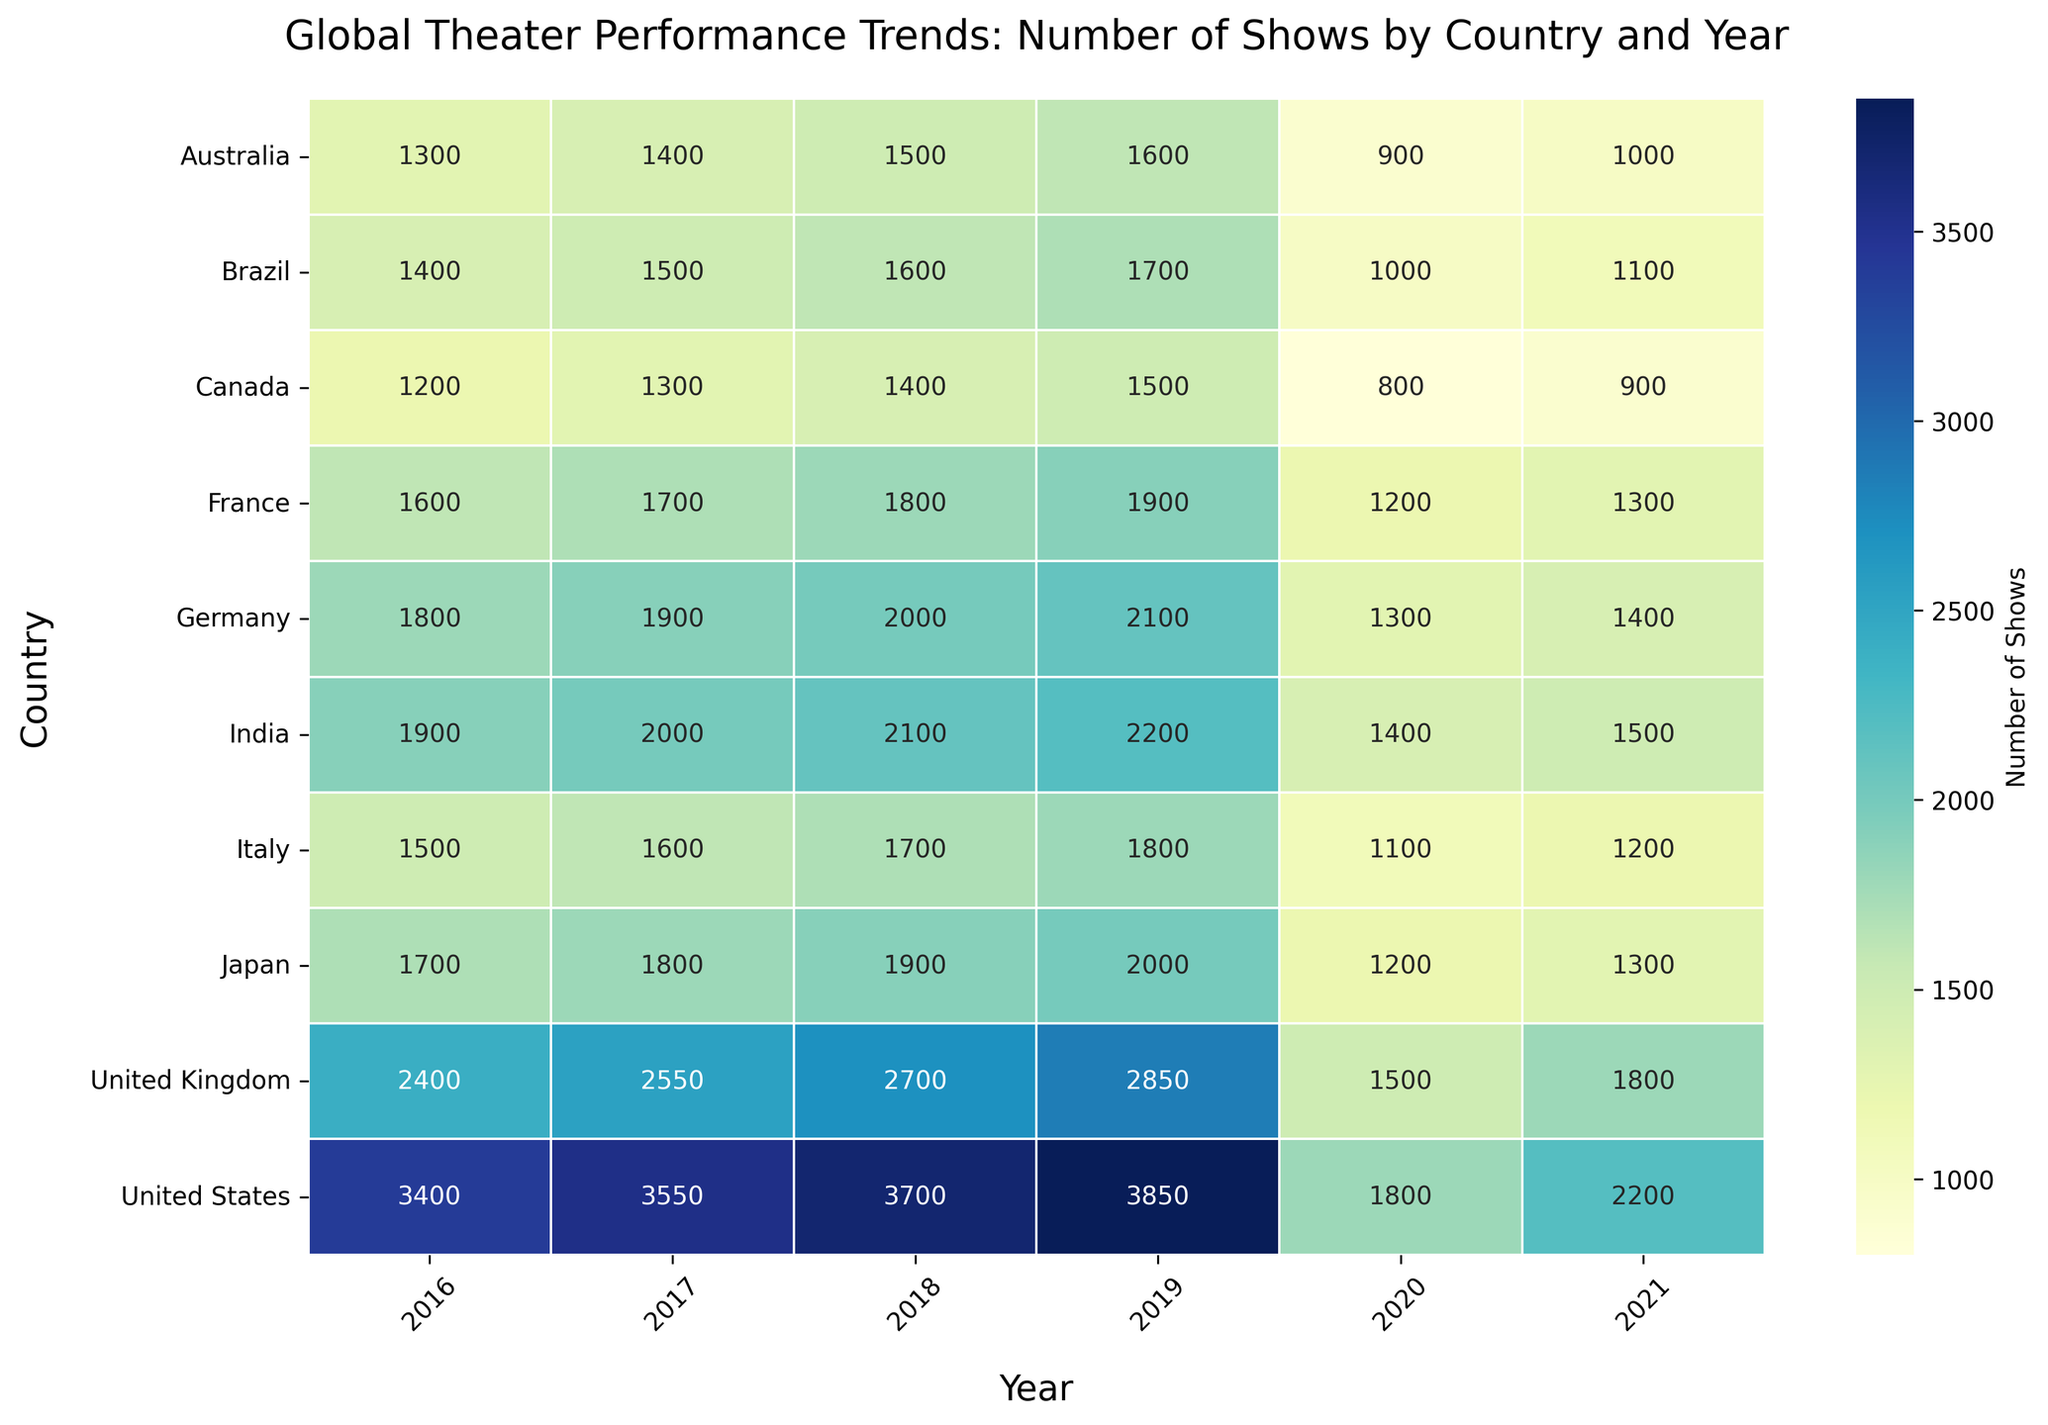What country had the highest number of theater shows in 2019? Look at the row corresponding to 2019 and find the country with the highest value. The United States has the highest number with 3850 shows.
Answer: United States Which country had a larger decrease in the number of shows from 2019 to 2020, the United States or the United Kingdom? Compare the difference between the Number of Shows in 2019 and 2020 for both countries. The United States decreased from 3850 to 1800, a difference of 2050. The United Kingdom decreased from 2850 to 1500, a difference of 1350. The United States had a larger decrease.
Answer: United States What is the average number of shows in Germany from 2016 to 2021? Sum the Number of Shows for Germany for each year from 2016 to 2021 and divide by the number of years. (1800 + 1900 + 2000 + 2100 + 1300 + 1400) / 6 = 17583 / 6, which is approximately 1750.
Answer: 1750 Did Australia see an increase or decrease in the number of shows from 2018 to 2019? Compare the Number of Shows in Australia for 2018 and 2019. The numbers are 1500 in 2018 and 1600 in 2019, which indicates an increase.
Answer: Increase Which country experienced the smallest change in the number of shows from 2020 to 2021? Calculate the difference between the Number of Shows in 2020 and 2021 for each country. The differences are: 
United States: 2200-1800 = 400, 
United Kingdom: 1800-1500 = 300, 
Germany: 1400-1300 = 100, 
France: 1300-1200 = 100, 
India: 1500-1400 = 100, 
Australia: 1000-900 = 100, 
Canada: 900-800 = 100, 
Japan: 1300-1200 = 100, 
Brazil: 1100-1000 = 100, 
Italy: 1200-1100 = 100.
The smallest change is 100, which applies to several countries.
Answer: Germany, France, India, Australia, Canada, Japan, Brazil, Italy Which year showed the highest variance in the number of theater shows across all countries? For each year calculate the variance in the Number of Shows across all countries. The year with the highest calculated variance will be the answer. After performing the calculations, you'll find that the variance is highest for the year 2020.
Answer: 2020 By how much did the total number of theater shows in France change from 2016 to 2021? Subtract the Number of Shows in France in 2016 from the number in 2021. The numbers are 1300 in 2021 and 1600 in 2016, so the change is 1300 - 1600 = -300, indicating a decrease of 300.
Answer: -300 What was the relative change in the number of shows for Japan between 2019 and 2020? Calculate the relative change using the formula (New Value - Old Value) / Old Value. For Japan, it is (1200 - 2000) / 2000 = -800 / 2000 = -0.4, or a 40% decrease.
Answer: -40% Which country had the most consistent number of shows from 2016 to 2019? Examine the Number of Shows from 2016 to 2019 for each country and identify the one with the least fluctuation in values. From the values, it appears that the United States had fairly consistent increases over these years without any drastic fluctuations, making it the most consistent.
Answer: United States 